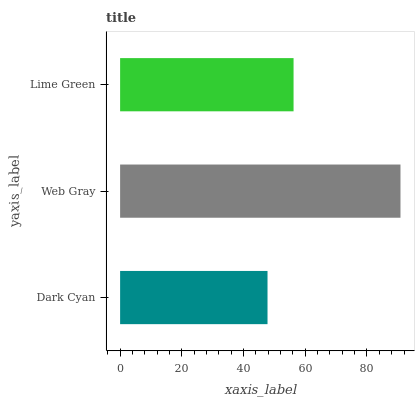Is Dark Cyan the minimum?
Answer yes or no. Yes. Is Web Gray the maximum?
Answer yes or no. Yes. Is Lime Green the minimum?
Answer yes or no. No. Is Lime Green the maximum?
Answer yes or no. No. Is Web Gray greater than Lime Green?
Answer yes or no. Yes. Is Lime Green less than Web Gray?
Answer yes or no. Yes. Is Lime Green greater than Web Gray?
Answer yes or no. No. Is Web Gray less than Lime Green?
Answer yes or no. No. Is Lime Green the high median?
Answer yes or no. Yes. Is Lime Green the low median?
Answer yes or no. Yes. Is Dark Cyan the high median?
Answer yes or no. No. Is Dark Cyan the low median?
Answer yes or no. No. 